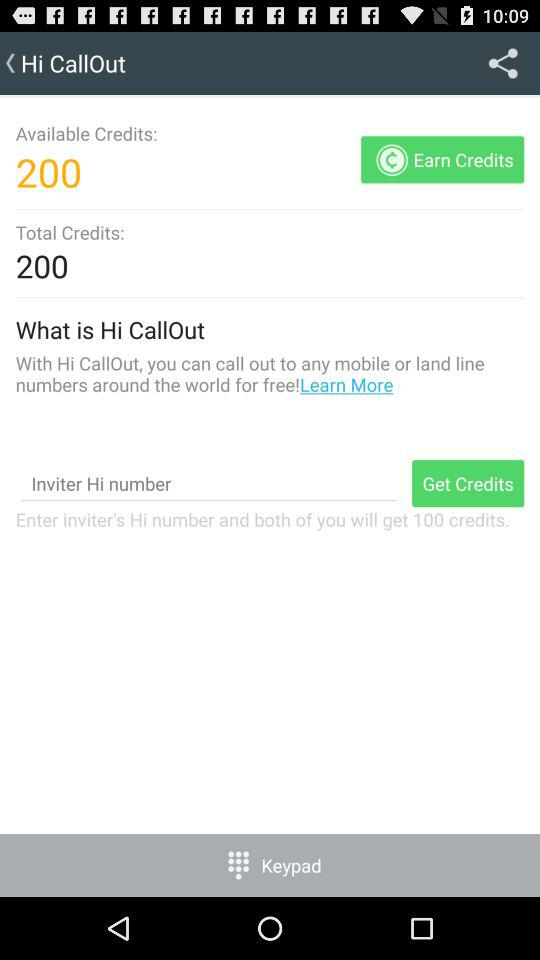What are the available credits? The available credits are 200. 